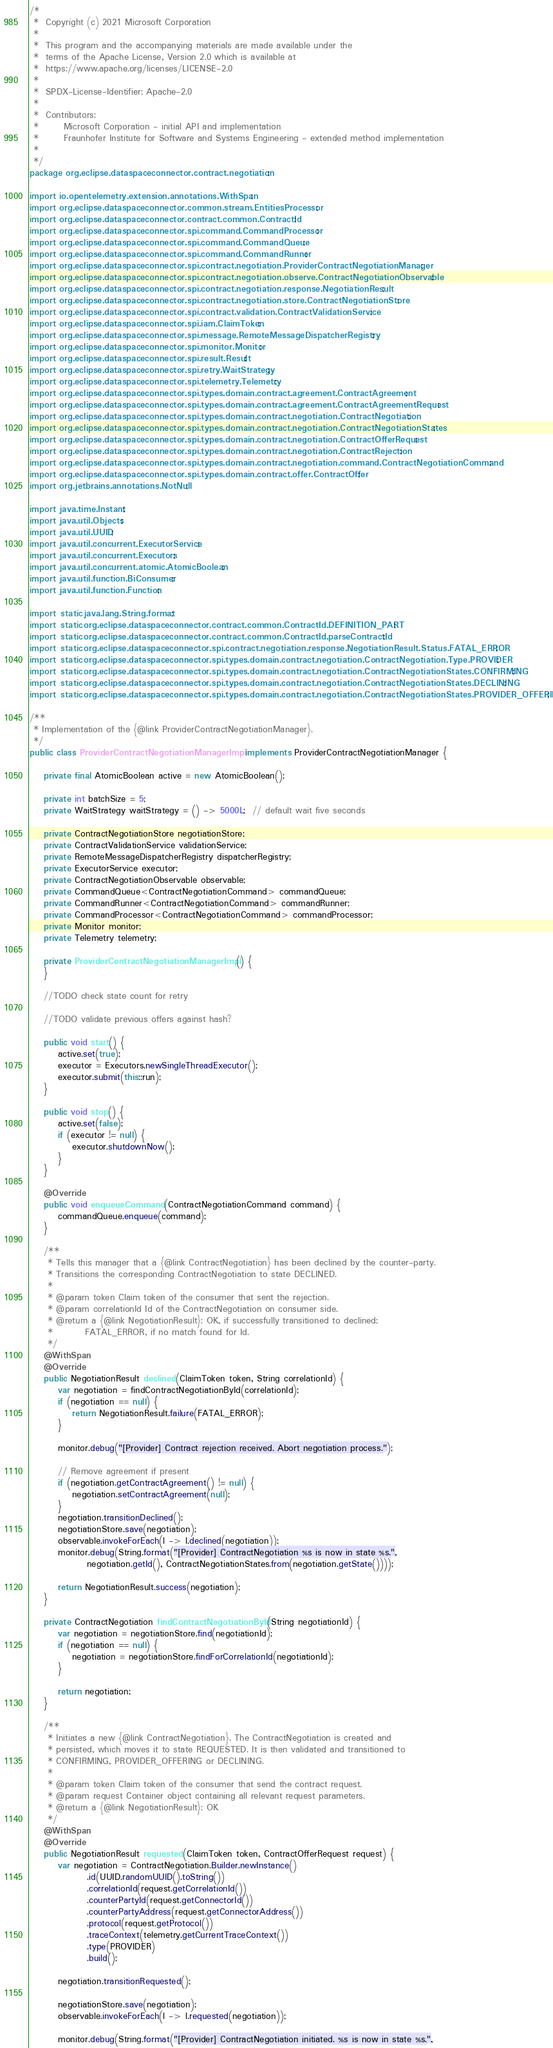Convert code to text. <code><loc_0><loc_0><loc_500><loc_500><_Java_>/*
 *  Copyright (c) 2021 Microsoft Corporation
 *
 *  This program and the accompanying materials are made available under the
 *  terms of the Apache License, Version 2.0 which is available at
 *  https://www.apache.org/licenses/LICENSE-2.0
 *
 *  SPDX-License-Identifier: Apache-2.0
 *
 *  Contributors:
 *       Microsoft Corporation - initial API and implementation
 *       Fraunhofer Institute for Software and Systems Engineering - extended method implementation
 *
 */
package org.eclipse.dataspaceconnector.contract.negotiation;

import io.opentelemetry.extension.annotations.WithSpan;
import org.eclipse.dataspaceconnector.common.stream.EntitiesProcessor;
import org.eclipse.dataspaceconnector.contract.common.ContractId;
import org.eclipse.dataspaceconnector.spi.command.CommandProcessor;
import org.eclipse.dataspaceconnector.spi.command.CommandQueue;
import org.eclipse.dataspaceconnector.spi.command.CommandRunner;
import org.eclipse.dataspaceconnector.spi.contract.negotiation.ProviderContractNegotiationManager;
import org.eclipse.dataspaceconnector.spi.contract.negotiation.observe.ContractNegotiationObservable;
import org.eclipse.dataspaceconnector.spi.contract.negotiation.response.NegotiationResult;
import org.eclipse.dataspaceconnector.spi.contract.negotiation.store.ContractNegotiationStore;
import org.eclipse.dataspaceconnector.spi.contract.validation.ContractValidationService;
import org.eclipse.dataspaceconnector.spi.iam.ClaimToken;
import org.eclipse.dataspaceconnector.spi.message.RemoteMessageDispatcherRegistry;
import org.eclipse.dataspaceconnector.spi.monitor.Monitor;
import org.eclipse.dataspaceconnector.spi.result.Result;
import org.eclipse.dataspaceconnector.spi.retry.WaitStrategy;
import org.eclipse.dataspaceconnector.spi.telemetry.Telemetry;
import org.eclipse.dataspaceconnector.spi.types.domain.contract.agreement.ContractAgreement;
import org.eclipse.dataspaceconnector.spi.types.domain.contract.agreement.ContractAgreementRequest;
import org.eclipse.dataspaceconnector.spi.types.domain.contract.negotiation.ContractNegotiation;
import org.eclipse.dataspaceconnector.spi.types.domain.contract.negotiation.ContractNegotiationStates;
import org.eclipse.dataspaceconnector.spi.types.domain.contract.negotiation.ContractOfferRequest;
import org.eclipse.dataspaceconnector.spi.types.domain.contract.negotiation.ContractRejection;
import org.eclipse.dataspaceconnector.spi.types.domain.contract.negotiation.command.ContractNegotiationCommand;
import org.eclipse.dataspaceconnector.spi.types.domain.contract.offer.ContractOffer;
import org.jetbrains.annotations.NotNull;

import java.time.Instant;
import java.util.Objects;
import java.util.UUID;
import java.util.concurrent.ExecutorService;
import java.util.concurrent.Executors;
import java.util.concurrent.atomic.AtomicBoolean;
import java.util.function.BiConsumer;
import java.util.function.Function;

import static java.lang.String.format;
import static org.eclipse.dataspaceconnector.contract.common.ContractId.DEFINITION_PART;
import static org.eclipse.dataspaceconnector.contract.common.ContractId.parseContractId;
import static org.eclipse.dataspaceconnector.spi.contract.negotiation.response.NegotiationResult.Status.FATAL_ERROR;
import static org.eclipse.dataspaceconnector.spi.types.domain.contract.negotiation.ContractNegotiation.Type.PROVIDER;
import static org.eclipse.dataspaceconnector.spi.types.domain.contract.negotiation.ContractNegotiationStates.CONFIRMING;
import static org.eclipse.dataspaceconnector.spi.types.domain.contract.negotiation.ContractNegotiationStates.DECLINING;
import static org.eclipse.dataspaceconnector.spi.types.domain.contract.negotiation.ContractNegotiationStates.PROVIDER_OFFERING;

/**
 * Implementation of the {@link ProviderContractNegotiationManager}.
 */
public class ProviderContractNegotiationManagerImpl implements ProviderContractNegotiationManager {

    private final AtomicBoolean active = new AtomicBoolean();

    private int batchSize = 5;
    private WaitStrategy waitStrategy = () -> 5000L;  // default wait five seconds

    private ContractNegotiationStore negotiationStore;
    private ContractValidationService validationService;
    private RemoteMessageDispatcherRegistry dispatcherRegistry;
    private ExecutorService executor;
    private ContractNegotiationObservable observable;
    private CommandQueue<ContractNegotiationCommand> commandQueue;
    private CommandRunner<ContractNegotiationCommand> commandRunner;
    private CommandProcessor<ContractNegotiationCommand> commandProcessor;
    private Monitor monitor;
    private Telemetry telemetry;

    private ProviderContractNegotiationManagerImpl() {
    }

    //TODO check state count for retry

    //TODO validate previous offers against hash?

    public void start() {
        active.set(true);
        executor = Executors.newSingleThreadExecutor();
        executor.submit(this::run);
    }

    public void stop() {
        active.set(false);
        if (executor != null) {
            executor.shutdownNow();
        }
    }

    @Override
    public void enqueueCommand(ContractNegotiationCommand command) {
        commandQueue.enqueue(command);
    }

    /**
     * Tells this manager that a {@link ContractNegotiation} has been declined by the counter-party.
     * Transitions the corresponding ContractNegotiation to state DECLINED.
     *
     * @param token Claim token of the consumer that sent the rejection.
     * @param correlationId Id of the ContractNegotiation on consumer side.
     * @return a {@link NegotiationResult}: OK, if successfully transitioned to declined;
     *         FATAL_ERROR, if no match found for Id.
     */
    @WithSpan
    @Override
    public NegotiationResult declined(ClaimToken token, String correlationId) {
        var negotiation = findContractNegotiationById(correlationId);
        if (negotiation == null) {
            return NegotiationResult.failure(FATAL_ERROR);
        }

        monitor.debug("[Provider] Contract rejection received. Abort negotiation process.");

        // Remove agreement if present
        if (negotiation.getContractAgreement() != null) {
            negotiation.setContractAgreement(null);
        }
        negotiation.transitionDeclined();
        negotiationStore.save(negotiation);
        observable.invokeForEach(l -> l.declined(negotiation));
        monitor.debug(String.format("[Provider] ContractNegotiation %s is now in state %s.",
                negotiation.getId(), ContractNegotiationStates.from(negotiation.getState())));

        return NegotiationResult.success(negotiation);
    }

    private ContractNegotiation findContractNegotiationById(String negotiationId) {
        var negotiation = negotiationStore.find(negotiationId);
        if (negotiation == null) {
            negotiation = negotiationStore.findForCorrelationId(negotiationId);
        }

        return negotiation;
    }

    /**
     * Initiates a new {@link ContractNegotiation}. The ContractNegotiation is created and
     * persisted, which moves it to state REQUESTED. It is then validated and transitioned to
     * CONFIRMING, PROVIDER_OFFERING or DECLINING.
     *
     * @param token Claim token of the consumer that send the contract request.
     * @param request Container object containing all relevant request parameters.
     * @return a {@link NegotiationResult}: OK
     */
    @WithSpan
    @Override
    public NegotiationResult requested(ClaimToken token, ContractOfferRequest request) {
        var negotiation = ContractNegotiation.Builder.newInstance()
                .id(UUID.randomUUID().toString())
                .correlationId(request.getCorrelationId())
                .counterPartyId(request.getConnectorId())
                .counterPartyAddress(request.getConnectorAddress())
                .protocol(request.getProtocol())
                .traceContext(telemetry.getCurrentTraceContext())
                .type(PROVIDER)
                .build();

        negotiation.transitionRequested();

        negotiationStore.save(negotiation);
        observable.invokeForEach(l -> l.requested(negotiation));

        monitor.debug(String.format("[Provider] ContractNegotiation initiated. %s is now in state %s.",</code> 